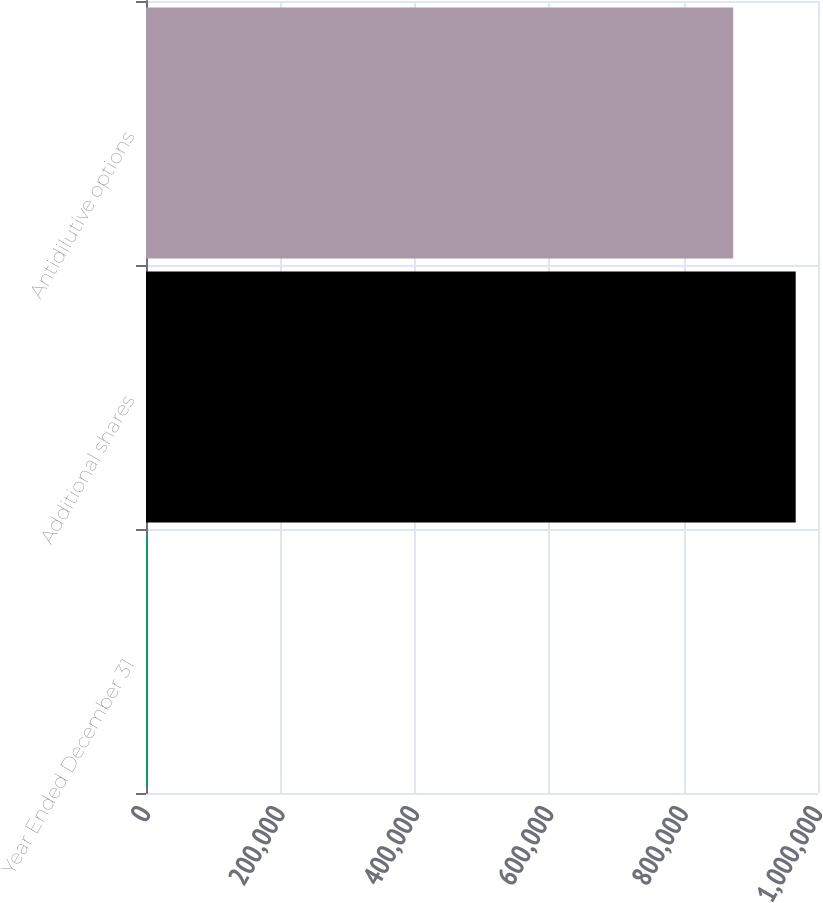<chart> <loc_0><loc_0><loc_500><loc_500><bar_chart><fcel>Year Ended December 31<fcel>Additional shares<fcel>Antidilutive options<nl><fcel>2013<fcel>966799<fcel>873800<nl></chart> 